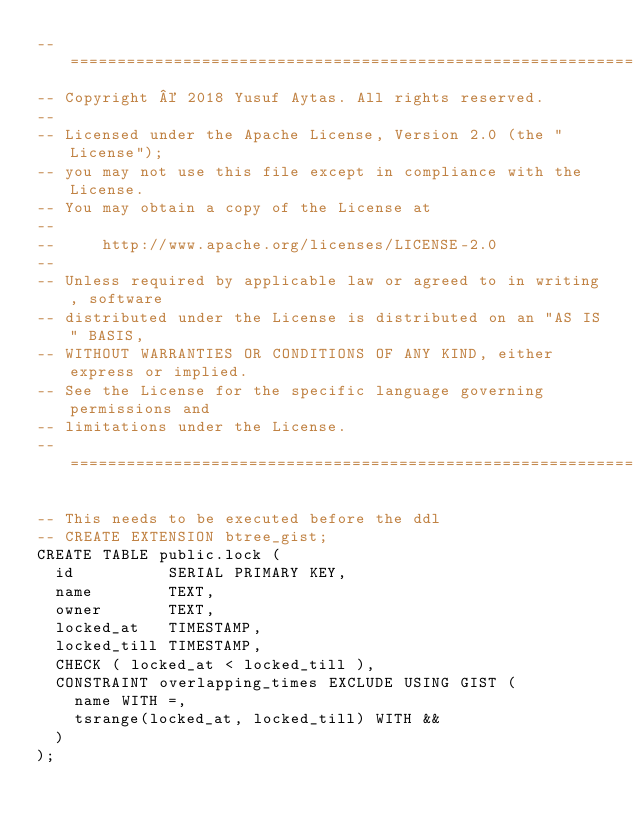Convert code to text. <code><loc_0><loc_0><loc_500><loc_500><_SQL_>-- =========================================================================
-- Copyright © 2018 Yusuf Aytas. All rights reserved.
--
-- Licensed under the Apache License, Version 2.0 (the "License");
-- you may not use this file except in compliance with the License.
-- You may obtain a copy of the License at
--
--     http://www.apache.org/licenses/LICENSE-2.0
--
-- Unless required by applicable law or agreed to in writing, software
-- distributed under the License is distributed on an "AS IS" BASIS,
-- WITHOUT WARRANTIES OR CONDITIONS OF ANY KIND, either express or implied.
-- See the License for the specific language governing permissions and
-- limitations under the License.
-- =========================================================================

-- This needs to be executed before the ddl
-- CREATE EXTENSION btree_gist;
CREATE TABLE public.lock (
  id          SERIAL PRIMARY KEY,
  name        TEXT,
  owner       TEXT,
  locked_at   TIMESTAMP,
  locked_till TIMESTAMP,
  CHECK ( locked_at < locked_till ),
  CONSTRAINT overlapping_times EXCLUDE USING GIST (
    name WITH =,
    tsrange(locked_at, locked_till) WITH &&
  )
);</code> 